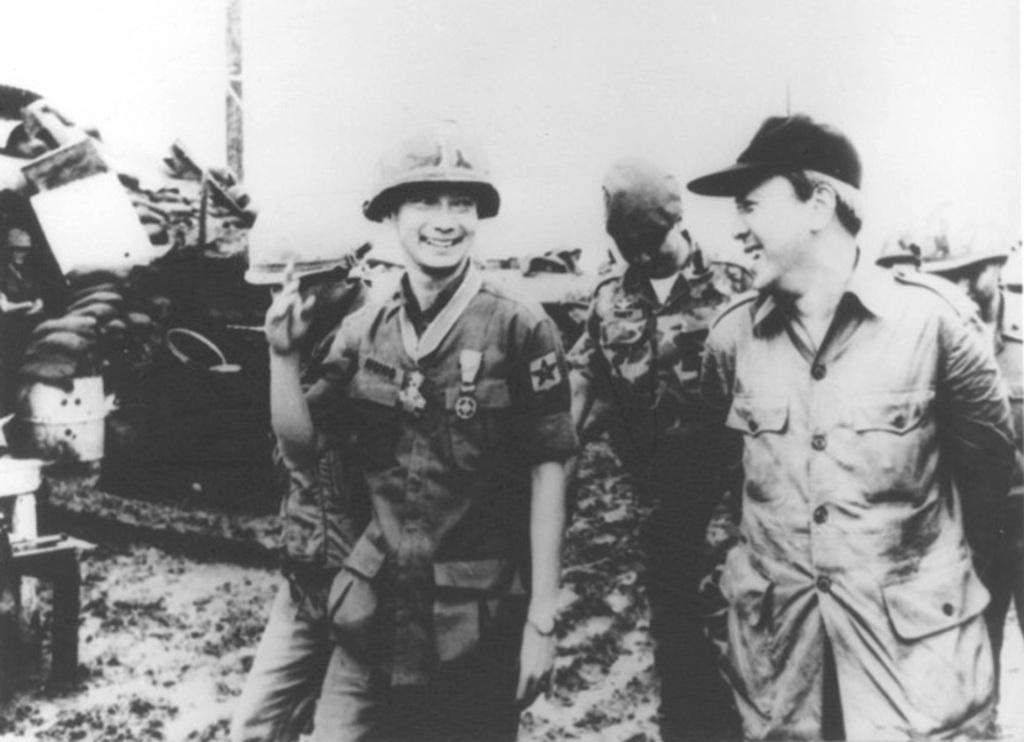What type of image is being described? The image is an old black and white picture. Who or what is present in the image? There are people in the image. What are the people doing in the image? The people are laughing and looking at each other. What can be seen in the background of the image? There are objects visible in the background of the image. What is the chance of rain in the image? There is no mention of weather or rain in the image, as it is an old black and white picture of people laughing and looking at each other. What type of skin is visible on the people in the image? The image is black and white, so it is not possible to determine the type of skin of the people in the image. 